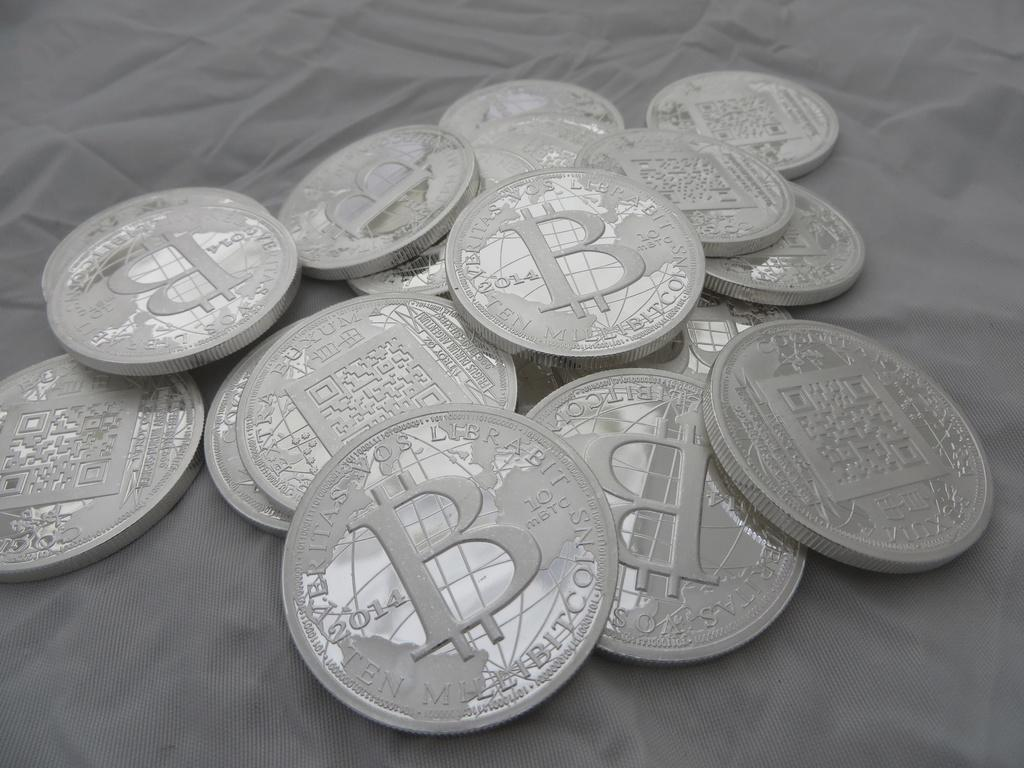<image>
Offer a succinct explanation of the picture presented. coins with a big B on them minted in 2014 